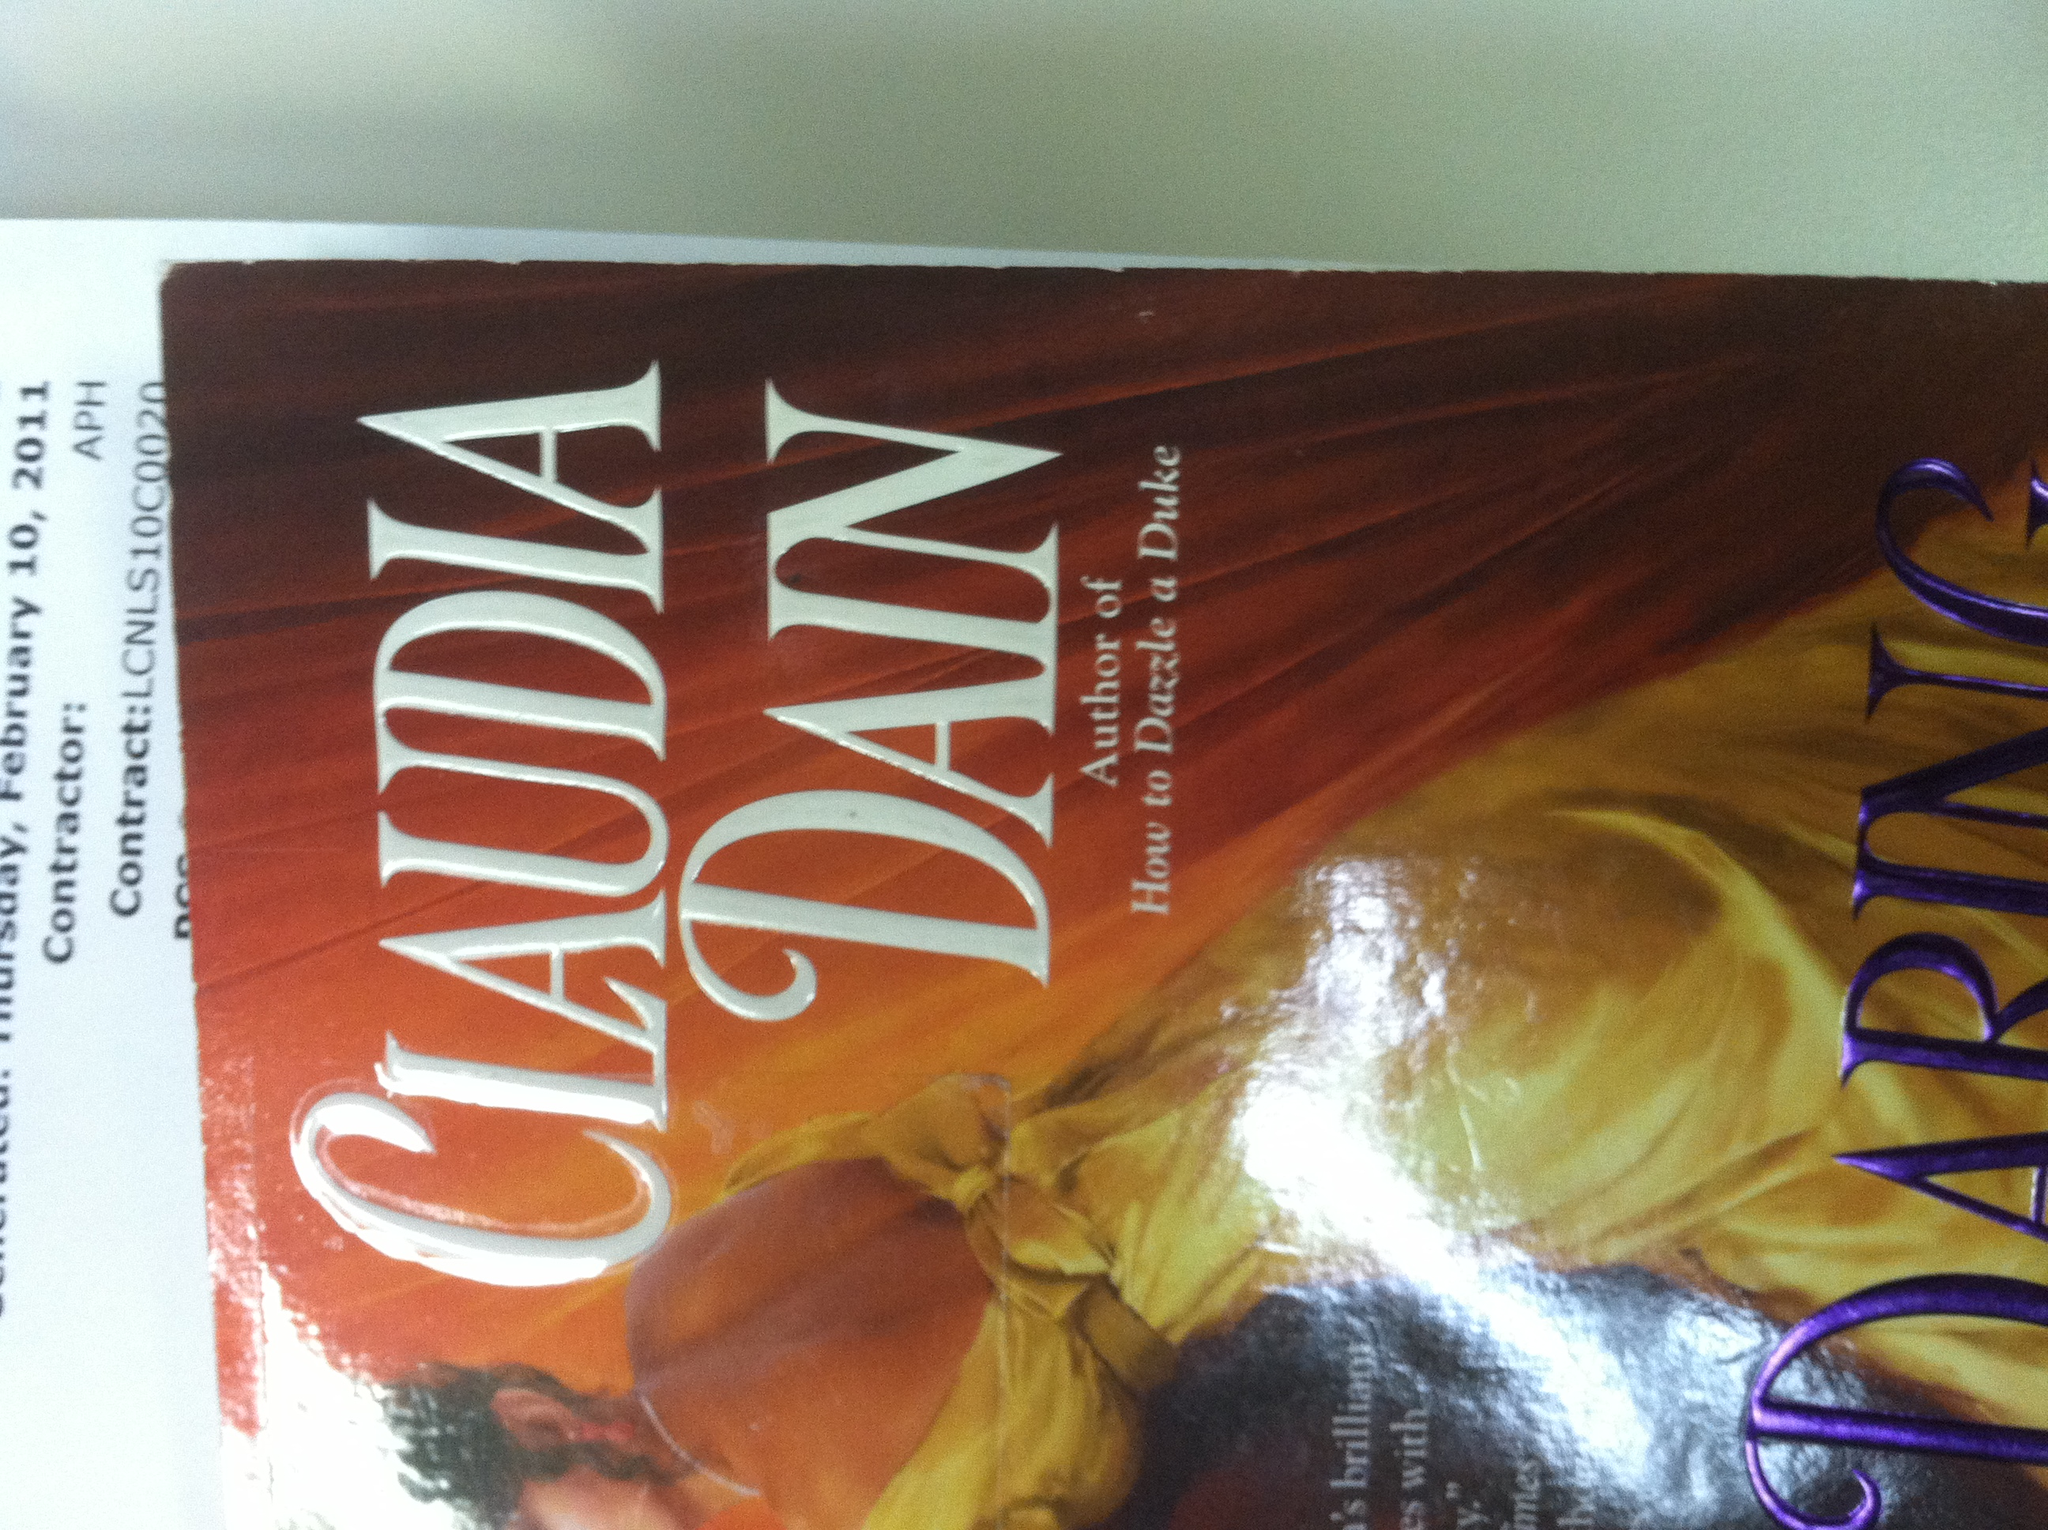Can you tell me about the author mentioned on this book cover? Claudia Dain is an author known for her historical romance novels. She has written several books that blend historical accuracy with engaging romance and intricate plots. 